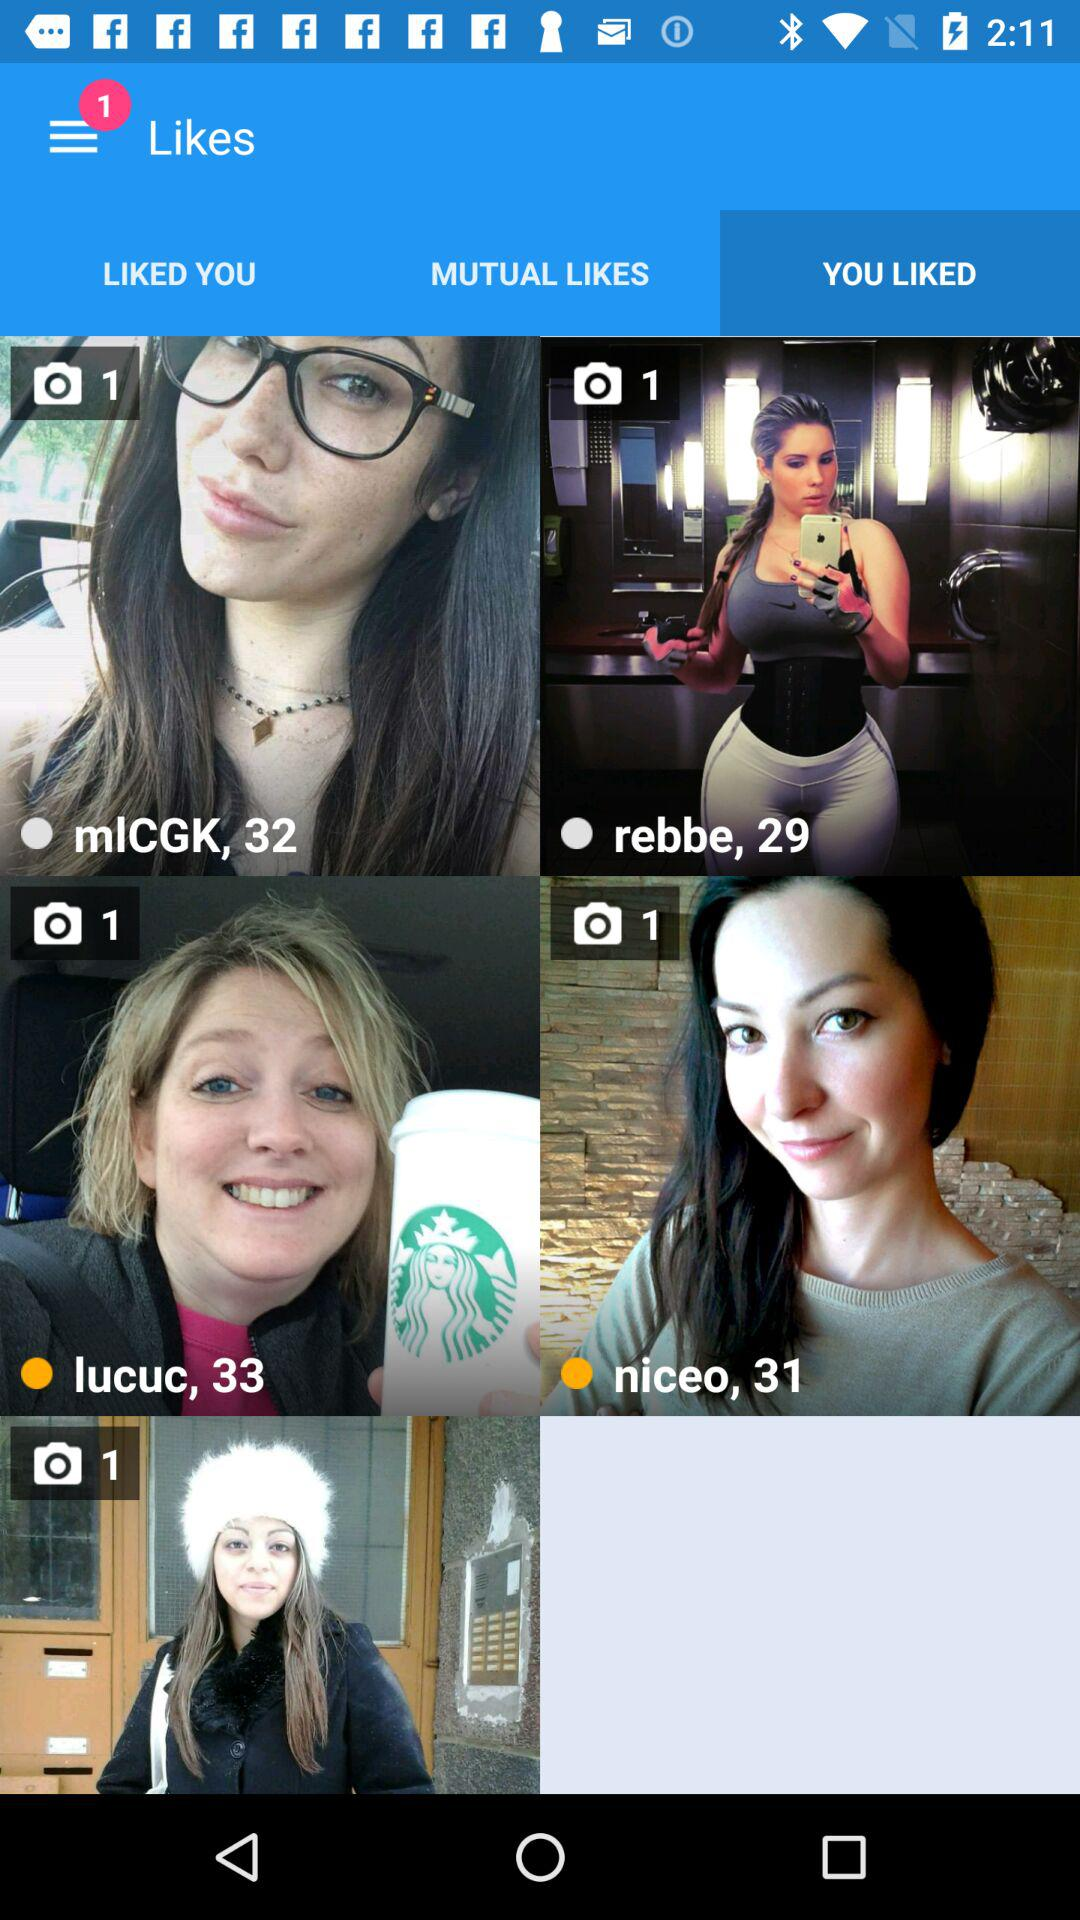How many unread notifications are shown there? There is 1 unread notification. 